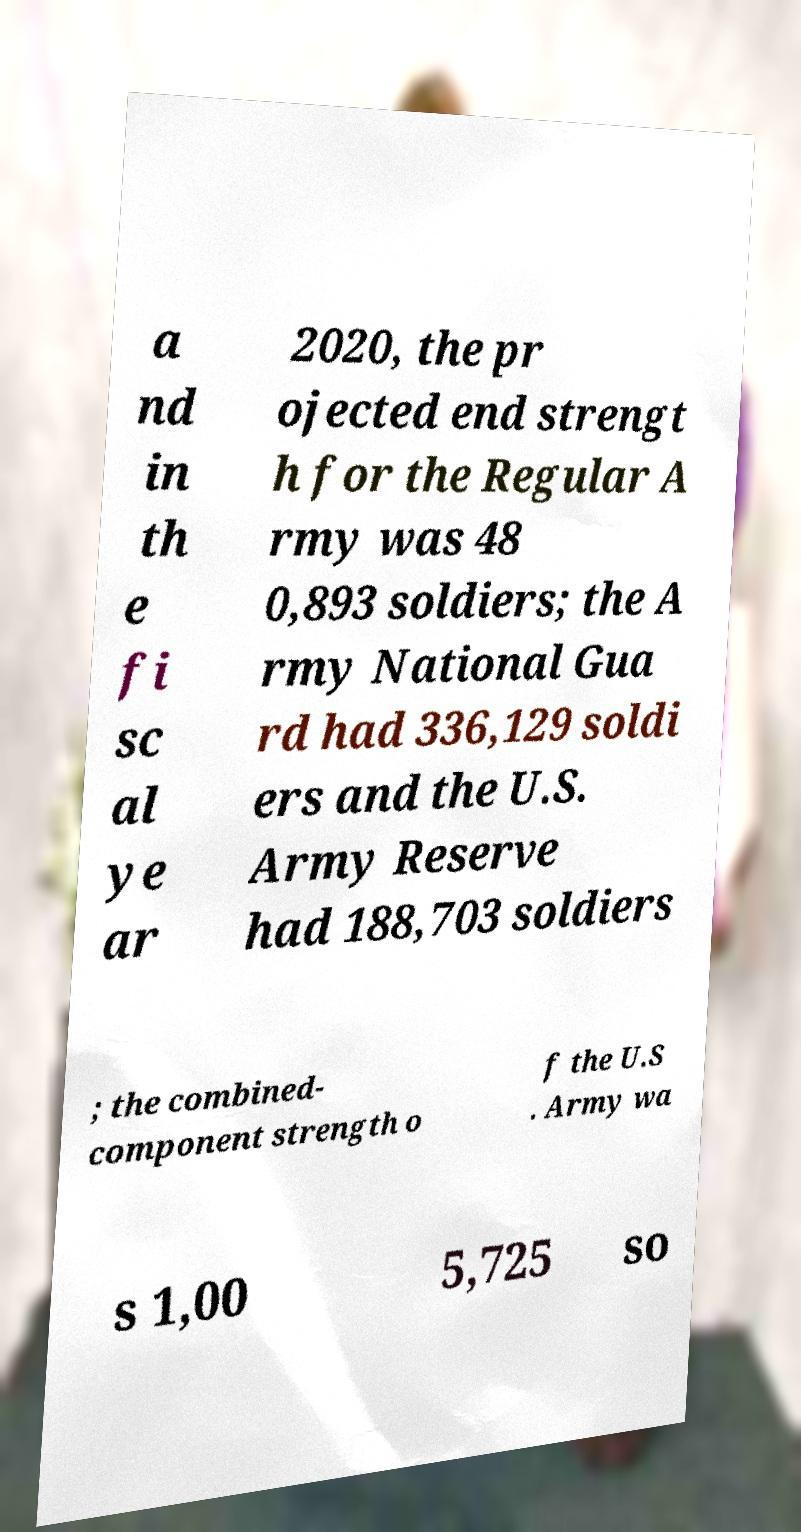What messages or text are displayed in this image? I need them in a readable, typed format. a nd in th e fi sc al ye ar 2020, the pr ojected end strengt h for the Regular A rmy was 48 0,893 soldiers; the A rmy National Gua rd had 336,129 soldi ers and the U.S. Army Reserve had 188,703 soldiers ; the combined- component strength o f the U.S . Army wa s 1,00 5,725 so 